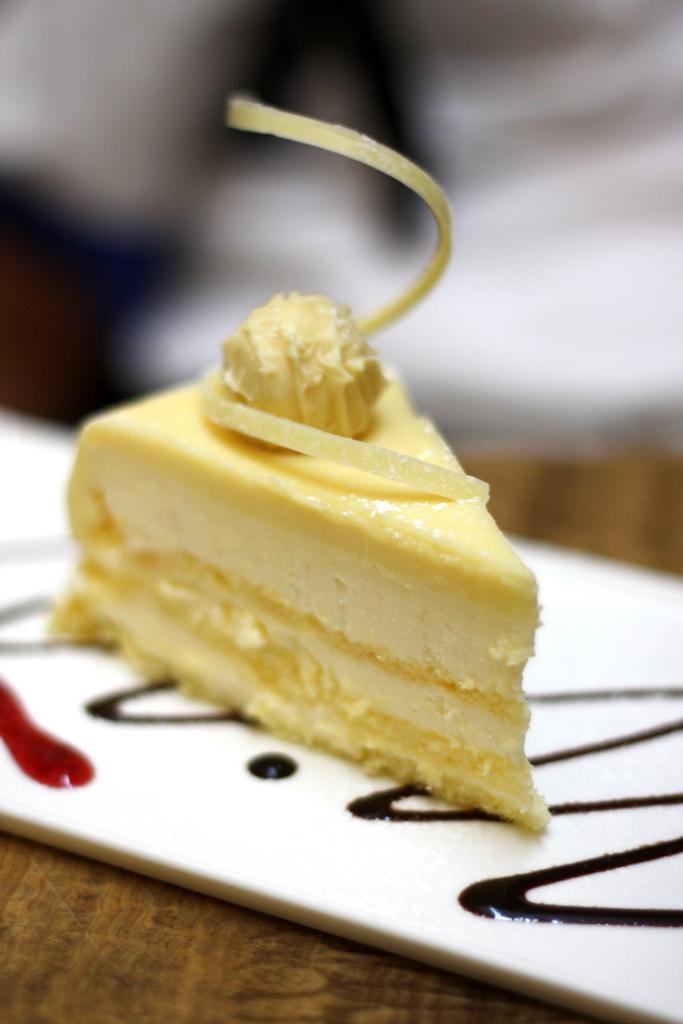In one or two sentences, can you explain what this image depicts? In this image we can see cake on the plate, which is on the wooden surface, and the background is blurred. 